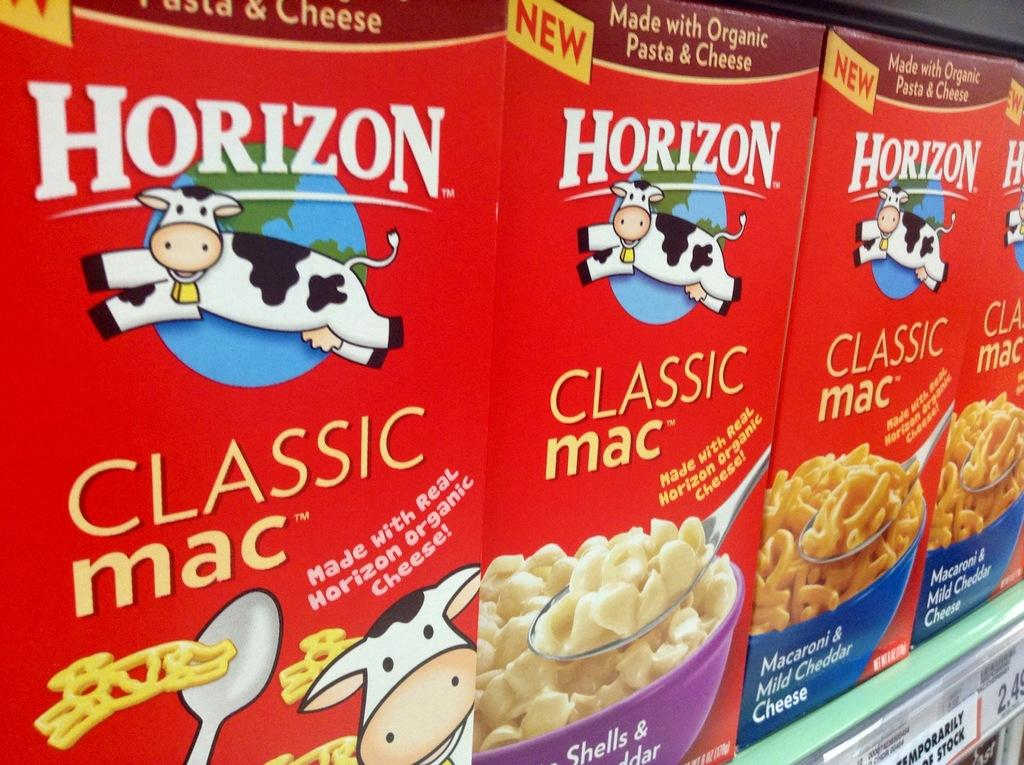What can be seen on the racks in the image? There are food packets on the racks. Are there any additional details about the food packets or the racks? Price tags are present on the rack at the bottom right corner. What game is being played by the food packets in the image? There is no game being played by the food packets in the image; they are simply displayed on the racks. 